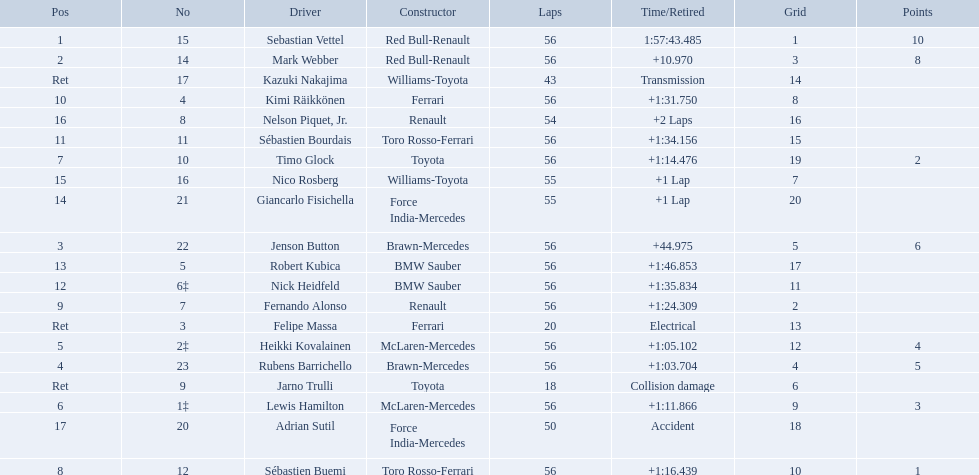Why did the  toyota retire Collision damage. What was the drivers name? Jarno Trulli. 